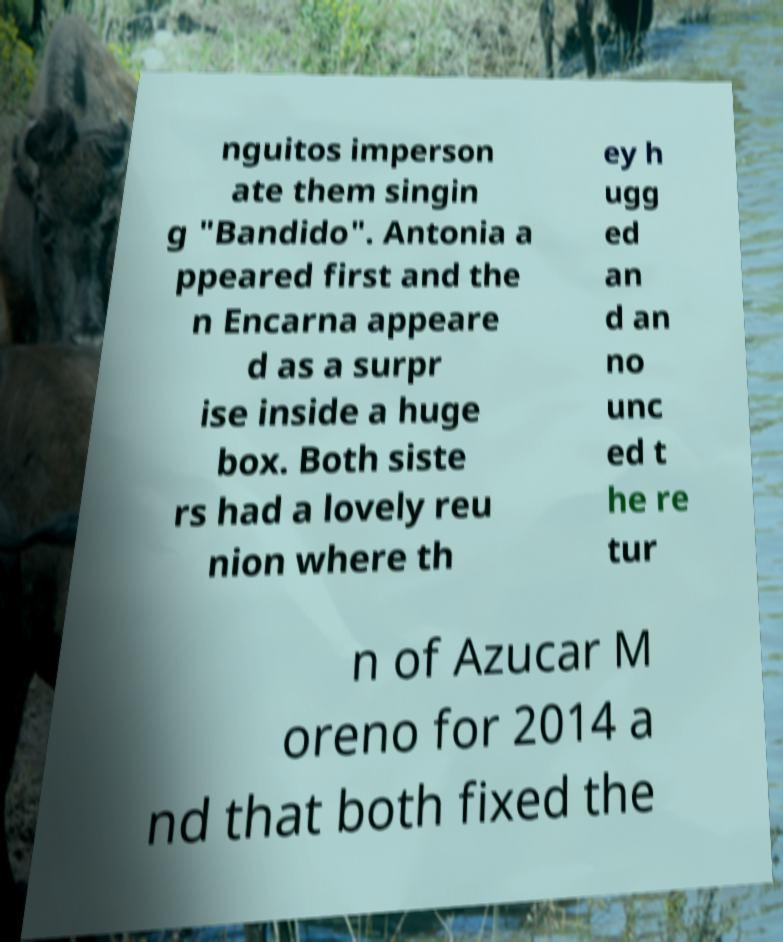Could you extract and type out the text from this image? nguitos imperson ate them singin g "Bandido". Antonia a ppeared first and the n Encarna appeare d as a surpr ise inside a huge box. Both siste rs had a lovely reu nion where th ey h ugg ed an d an no unc ed t he re tur n of Azucar M oreno for 2014 a nd that both fixed the 